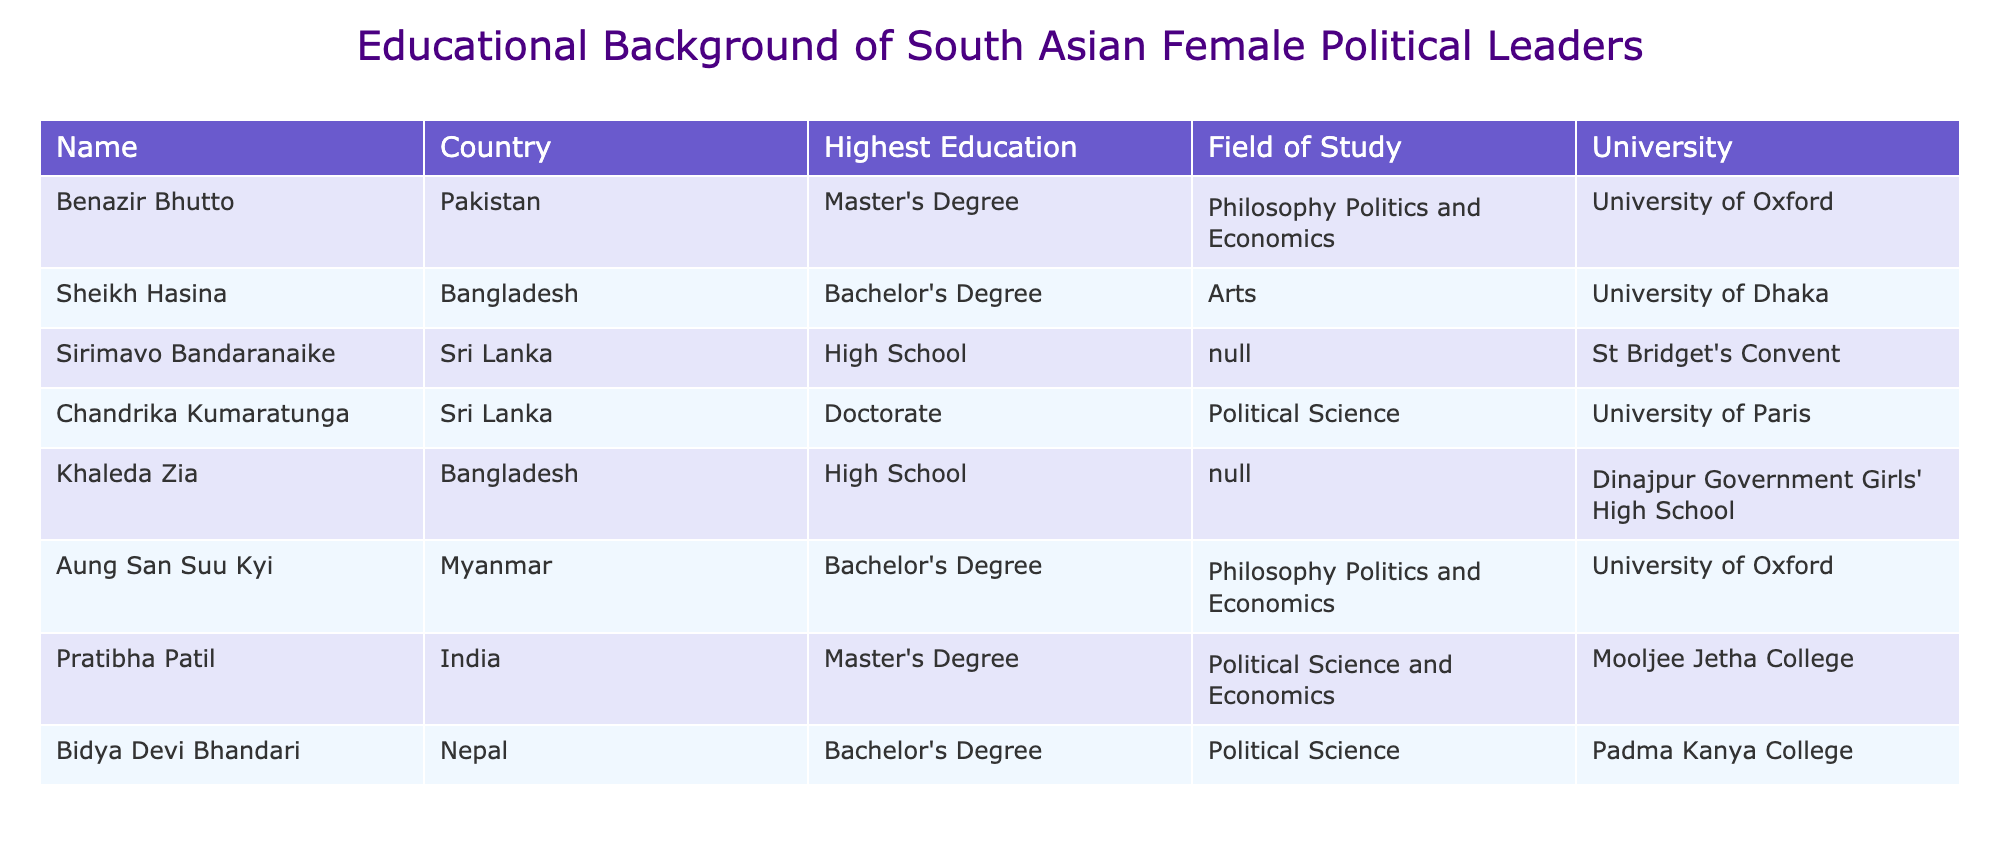What is the highest level of education attained by Benazir Bhutto? The table clearly states that Benazir Bhutto has attained a Master's Degree as her highest education.
Answer: Master's Degree Which university did Aung San Suu Kyi attend for her Bachelor's Degree? According to the table, Aung San Suu Kyi earned her Bachelor's Degree in Philosophy Politics and Economics from the University of Oxford.
Answer: University of Oxford How many female leaders in the table have a Doctorate degree? The table shows that only Chandrika Kumaratunga has a Doctorate degree, making it one female leader with that level of education.
Answer: 1 What is the average highest education level among the leaders listed? The highest education levels are Master's, Bachelor's, High School, and Doctorate. Converting them into a ranking system (Doctorate=4, Master's=3, Bachelor's=2, High School=1), the total ranking for the 8 leaders is (3+2+1+4+1+2+3+2)=18. Then, dividing by 8 gives us an average education level of 2.25, which corresponds to a Bachelor's Degree.
Answer: Bachelor's Degree Is it true that all leaders from the table are university graduates? The table indicates that not all leaders have university degrees, as both Sheikh Hasina and Khaleda Zia only have a Bachelor's Degree and High School education, respectively.
Answer: No Which country has the highest representation of leaders with a Master's Degree? Reviewing the table, it's evident that both Benazir Bhutto (Pakistan) and Pratibha Patil (India) have a Master's Degree, making their countries the highest represented in this category.
Answer: Pakistan and India How does the educational background of female leaders from Bangladesh compare to those from Sri Lanka in terms of the highest degree attained? In the table, Khaleda Zia from Bangladesh has only completed High School, while Chandrika Kumaratunga from Sri Lanka has a Doctorate. Therefore, the highest degree from Bangladesh is lower than that of Sri Lanka.
Answer: Bangladesh has a lower highest degree compared to Sri Lanka What percentage of the total leaders listed have a Bachelor's Degree? There are 3 leaders with a Bachelor's Degree (Aung San Suu Kyi, Sheikh Hasina, and Bidya Devi Bhandari) out of a total of 8 leaders. Thus, the percentage is calculated as (3/8)*100 = 37.5%.
Answer: 37.5% 